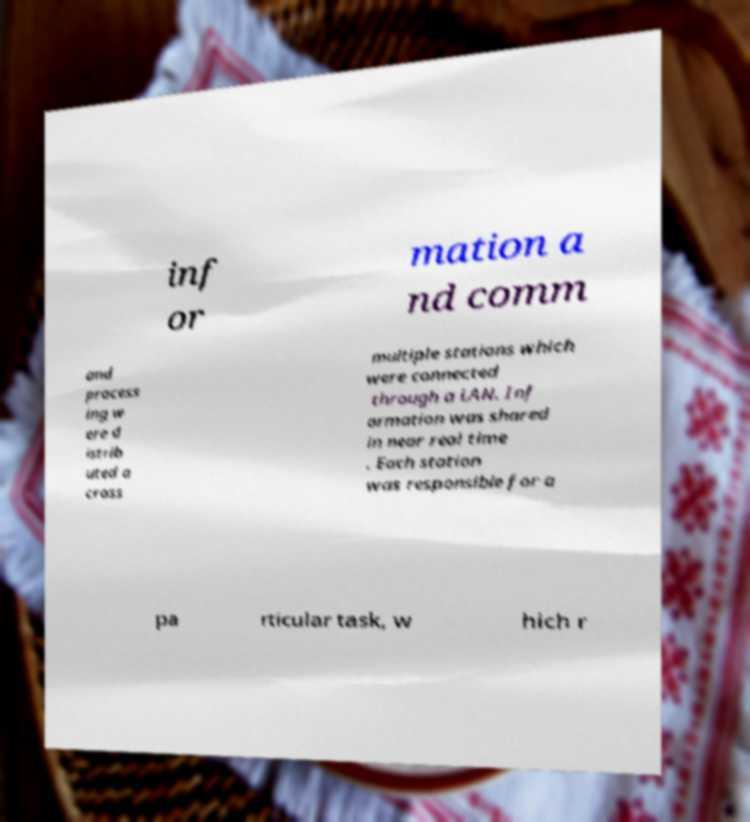Can you accurately transcribe the text from the provided image for me? inf or mation a nd comm and process ing w ere d istrib uted a cross multiple stations which were connected through a LAN. Inf ormation was shared in near real time . Each station was responsible for a pa rticular task, w hich r 